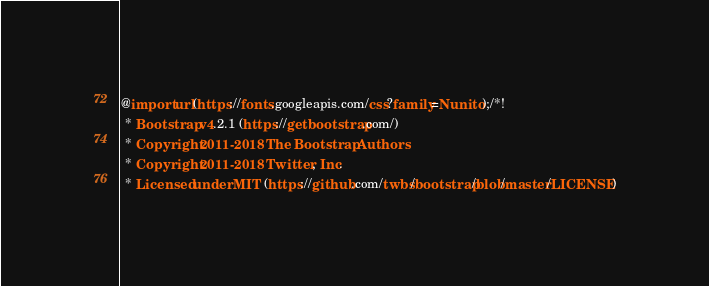<code> <loc_0><loc_0><loc_500><loc_500><_CSS_>@import url(https://fonts.googleapis.com/css?family=Nunito);/*!
 * Bootstrap v4.2.1 (https://getbootstrap.com/)
 * Copyright 2011-2018 The Bootstrap Authors
 * Copyright 2011-2018 Twitter, Inc.
 * Licensed under MIT (https://github.com/twbs/bootstrap/blob/master/LICENSE)</code> 